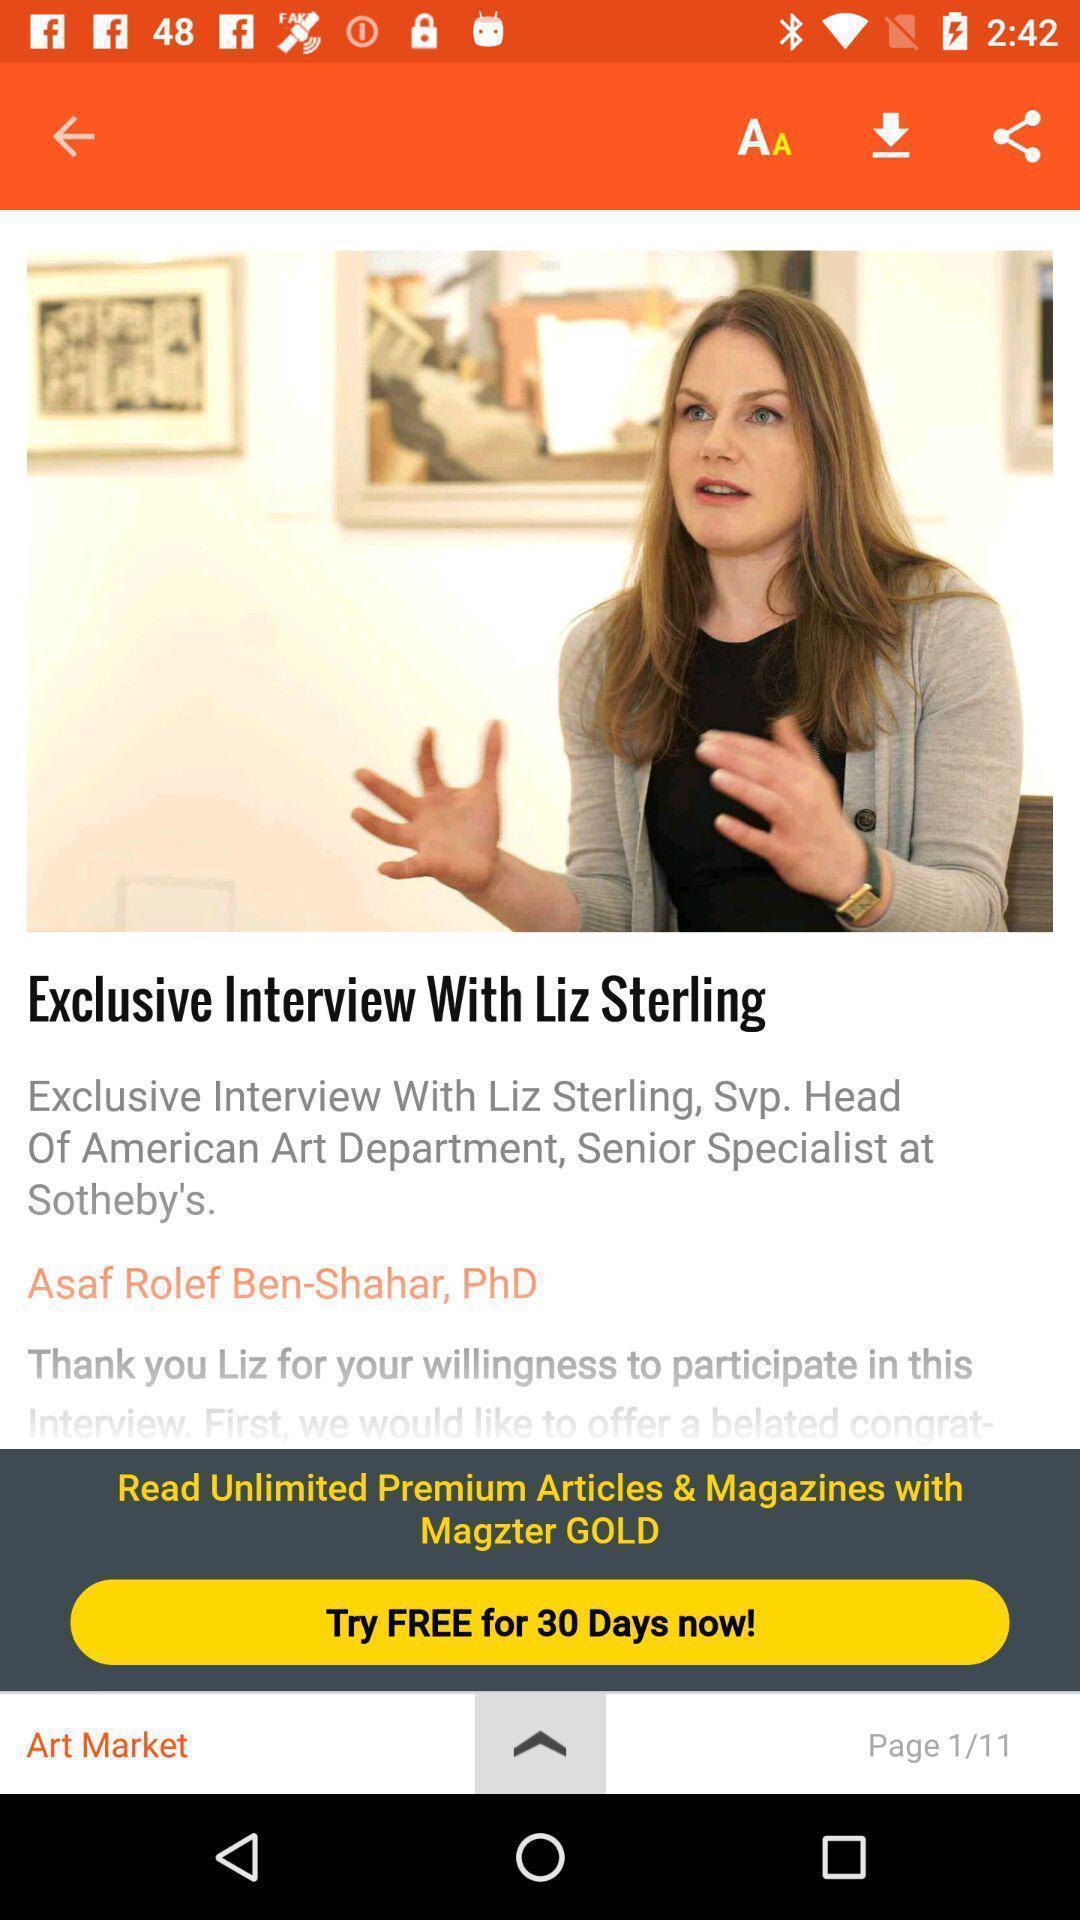What details can you identify in this image? Page showing interview details on a magazine app. 